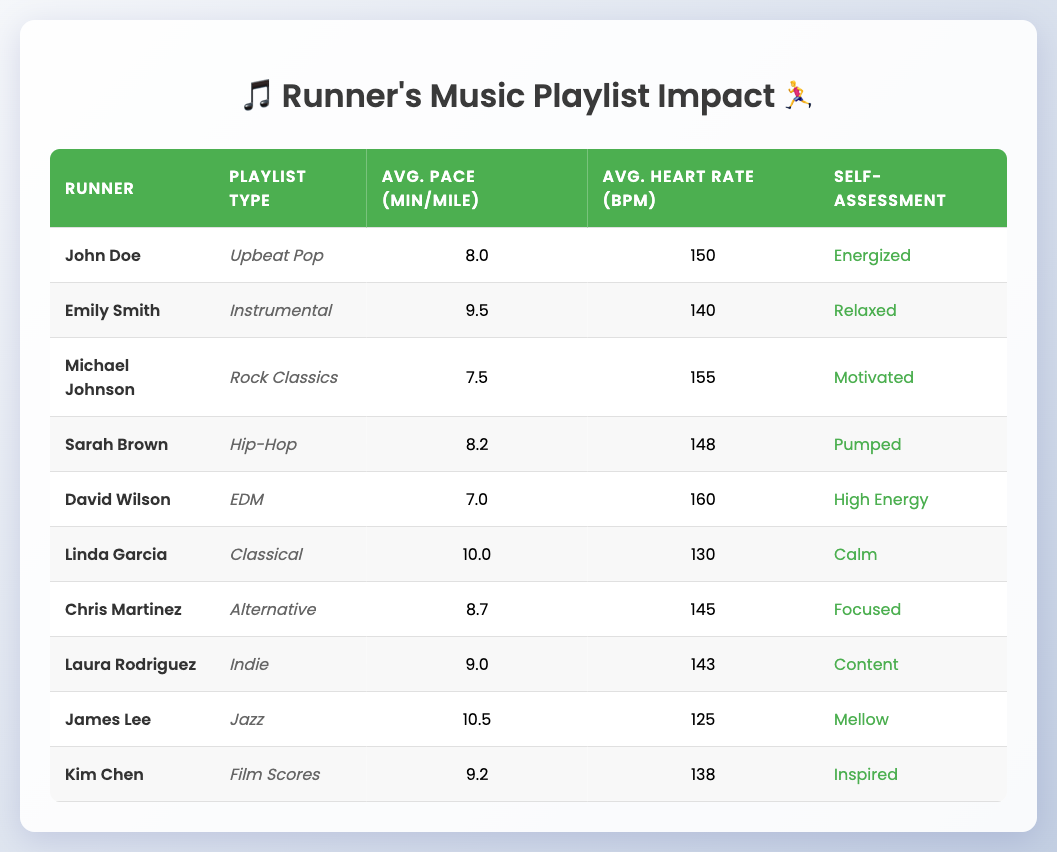What is the average pace for runners who prefer upbeat pop music? John Doe's average pace for upbeat pop is 8.0 minutes per mile. Since he is the only runner listed with that preference, the average is simply his pace.
Answer: 8.0 Which runner has the highest average heart rate and what type of music do they prefer? David Wilson has the highest average heart rate of 160 bpm. He prefers EDM music.
Answer: David Wilson, EDM Is there a runner who assesses themselves as "Calm"? Yes, Linda Garcia assesses herself as "Calm".
Answer: Yes What is the difference in average pace between the fastest and slowest runner in the table? The fastest runner is David Wilson with an average pace of 7.0 minutes per mile, and the slowest runner is James Lee with a pace of 10.5 minutes per mile. The difference is 10.5 - 7.0 = 3.5 minutes.
Answer: 3.5 minutes How many runners prefer a type of music that is known for being more energetic? There are four runners who prefer more energetic music: John Doe (Upbeat Pop), Michael Johnson (Rock Classics), Sarah Brown (Hip-Hop), and David Wilson (EDM).
Answer: 4 What is the average heart rate of runners who prefer Indie and Alternative music? Laura Rodriguez prefers Indie with an average heart rate of 143 bpm, and Chris Martinez prefers Alternative with 145 bpm. The average heart rate is (143 + 145)/2 = 144 bpm.
Answer: 144 Which playlist type corresponds to the runner who is self-assessed as "Pumped"? Sarah Brown is self-assessed as "Pumped" and her playlist type is Hip-Hop.
Answer: Hip-Hop Which type of music is preferred by the runner with the second slowest average pace? James Lee has the second slowest average pace of 10.5 minutes per mile. He prefers Jazz music.
Answer: Jazz 